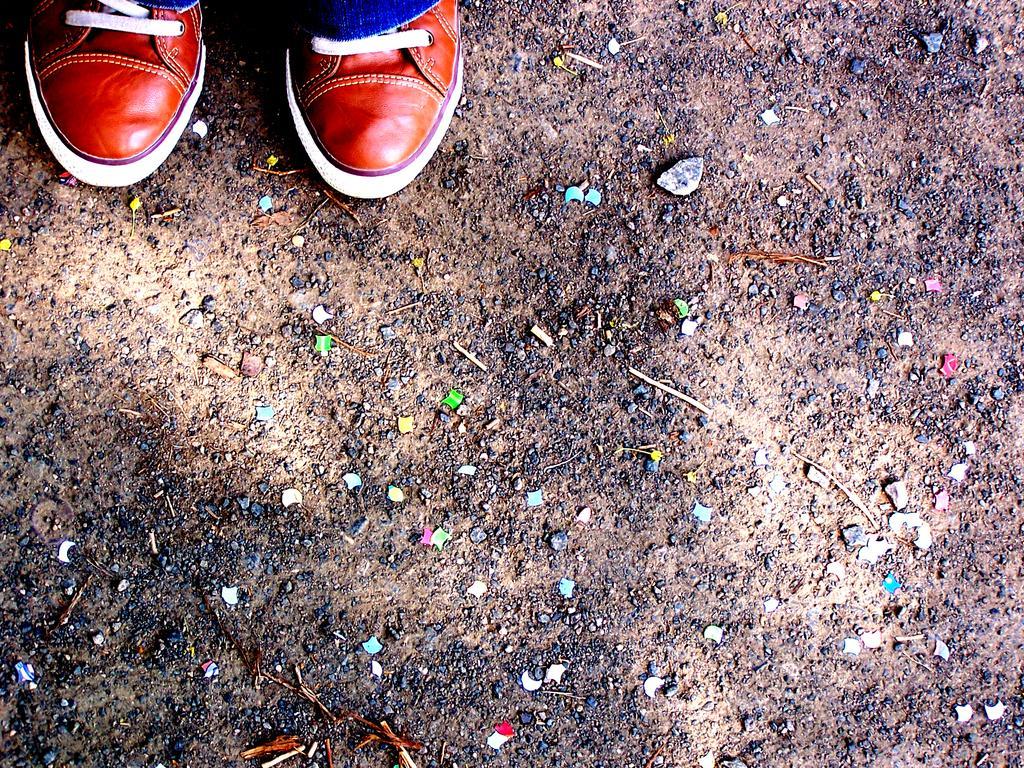Describe this image in one or two sentences. In this picture I can see pair of shoes and I can see small stones on the ground. 